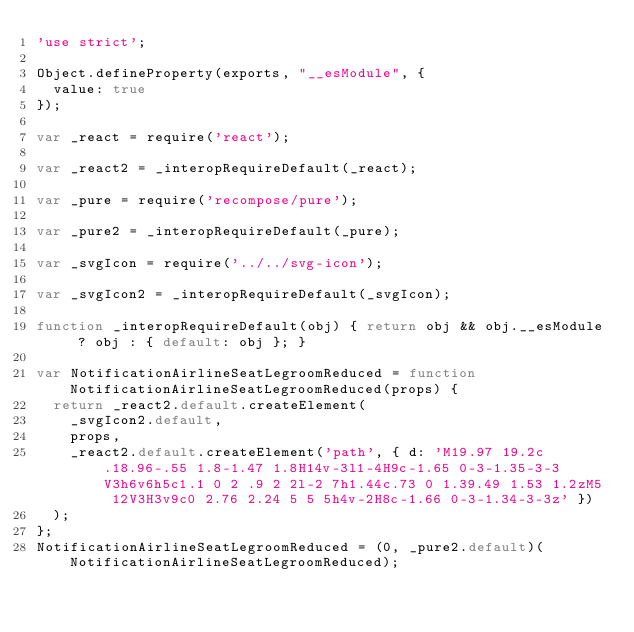Convert code to text. <code><loc_0><loc_0><loc_500><loc_500><_JavaScript_>'use strict';

Object.defineProperty(exports, "__esModule", {
  value: true
});

var _react = require('react');

var _react2 = _interopRequireDefault(_react);

var _pure = require('recompose/pure');

var _pure2 = _interopRequireDefault(_pure);

var _svgIcon = require('../../svg-icon');

var _svgIcon2 = _interopRequireDefault(_svgIcon);

function _interopRequireDefault(obj) { return obj && obj.__esModule ? obj : { default: obj }; }

var NotificationAirlineSeatLegroomReduced = function NotificationAirlineSeatLegroomReduced(props) {
  return _react2.default.createElement(
    _svgIcon2.default,
    props,
    _react2.default.createElement('path', { d: 'M19.97 19.2c.18.96-.55 1.8-1.47 1.8H14v-3l1-4H9c-1.65 0-3-1.35-3-3V3h6v6h5c1.1 0 2 .9 2 2l-2 7h1.44c.73 0 1.39.49 1.53 1.2zM5 12V3H3v9c0 2.76 2.24 5 5 5h4v-2H8c-1.66 0-3-1.34-3-3z' })
  );
};
NotificationAirlineSeatLegroomReduced = (0, _pure2.default)(NotificationAirlineSeatLegroomReduced);</code> 